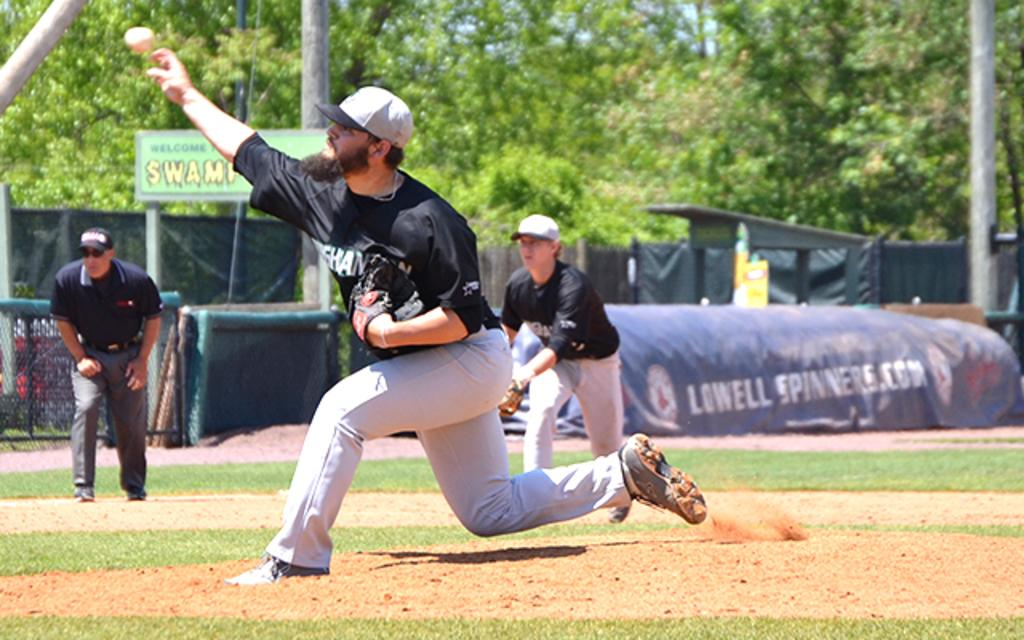<image>
Give a short and clear explanation of the subsequent image. A large tarp behind the baseball players advertises lowellspinners.com 